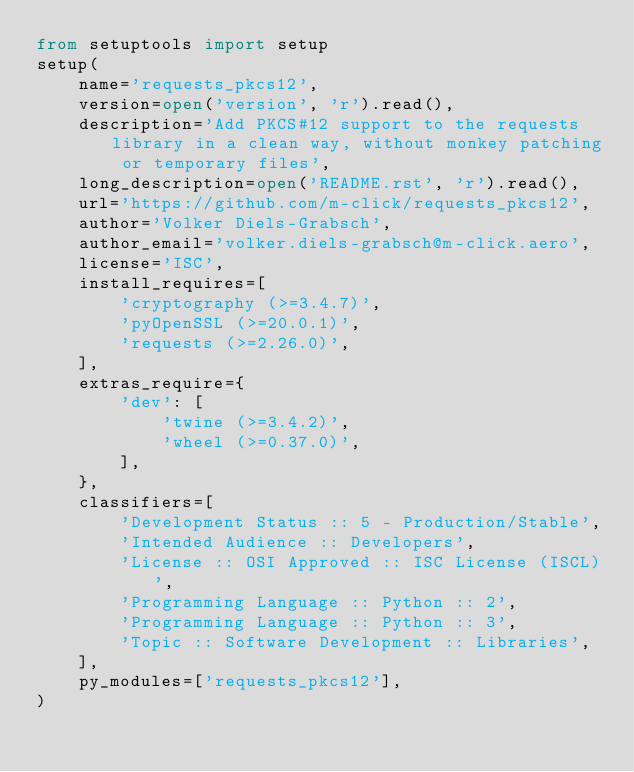<code> <loc_0><loc_0><loc_500><loc_500><_Python_>from setuptools import setup
setup(
    name='requests_pkcs12',
    version=open('version', 'r').read(),
    description='Add PKCS#12 support to the requests library in a clean way, without monkey patching or temporary files',
    long_description=open('README.rst', 'r').read(),
    url='https://github.com/m-click/requests_pkcs12',
    author='Volker Diels-Grabsch',
    author_email='volker.diels-grabsch@m-click.aero',
    license='ISC',
    install_requires=[
        'cryptography (>=3.4.7)',
        'pyOpenSSL (>=20.0.1)',
        'requests (>=2.26.0)',
    ],
    extras_require={
        'dev': [
            'twine (>=3.4.2)',
            'wheel (>=0.37.0)',
        ],
    },
    classifiers=[
        'Development Status :: 5 - Production/Stable',
        'Intended Audience :: Developers',
        'License :: OSI Approved :: ISC License (ISCL)',
        'Programming Language :: Python :: 2',
        'Programming Language :: Python :: 3',
        'Topic :: Software Development :: Libraries',
    ],
    py_modules=['requests_pkcs12'],
)
</code> 